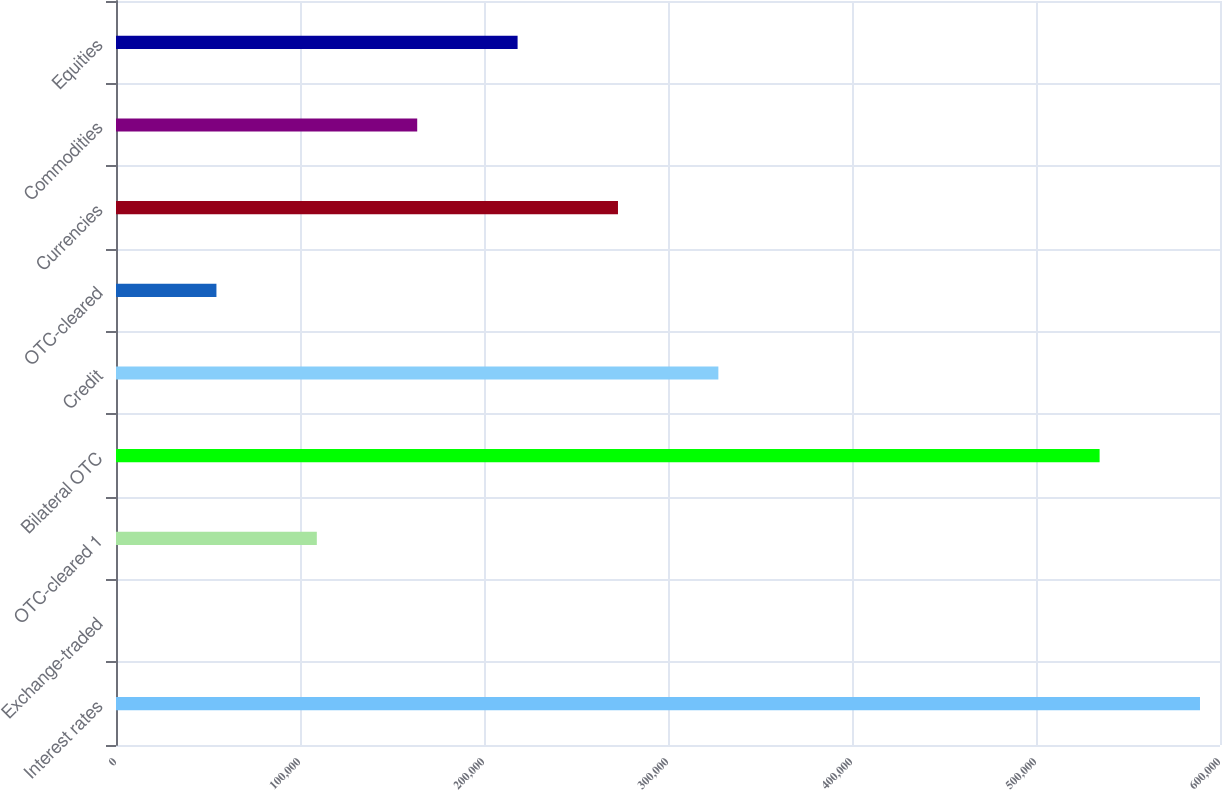Convert chart to OTSL. <chart><loc_0><loc_0><loc_500><loc_500><bar_chart><fcel>Interest rates<fcel>Exchange-traded<fcel>OTC-cleared 1<fcel>Bilateral OTC<fcel>Credit<fcel>OTC-cleared<fcel>Currencies<fcel>Commodities<fcel>Equities<nl><fcel>589126<fcel>26<fcel>109142<fcel>534568<fcel>327373<fcel>54583.9<fcel>272816<fcel>163700<fcel>218258<nl></chart> 